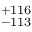<formula> <loc_0><loc_0><loc_500><loc_500>^ { + 1 1 6 } _ { - 1 1 3 }</formula> 